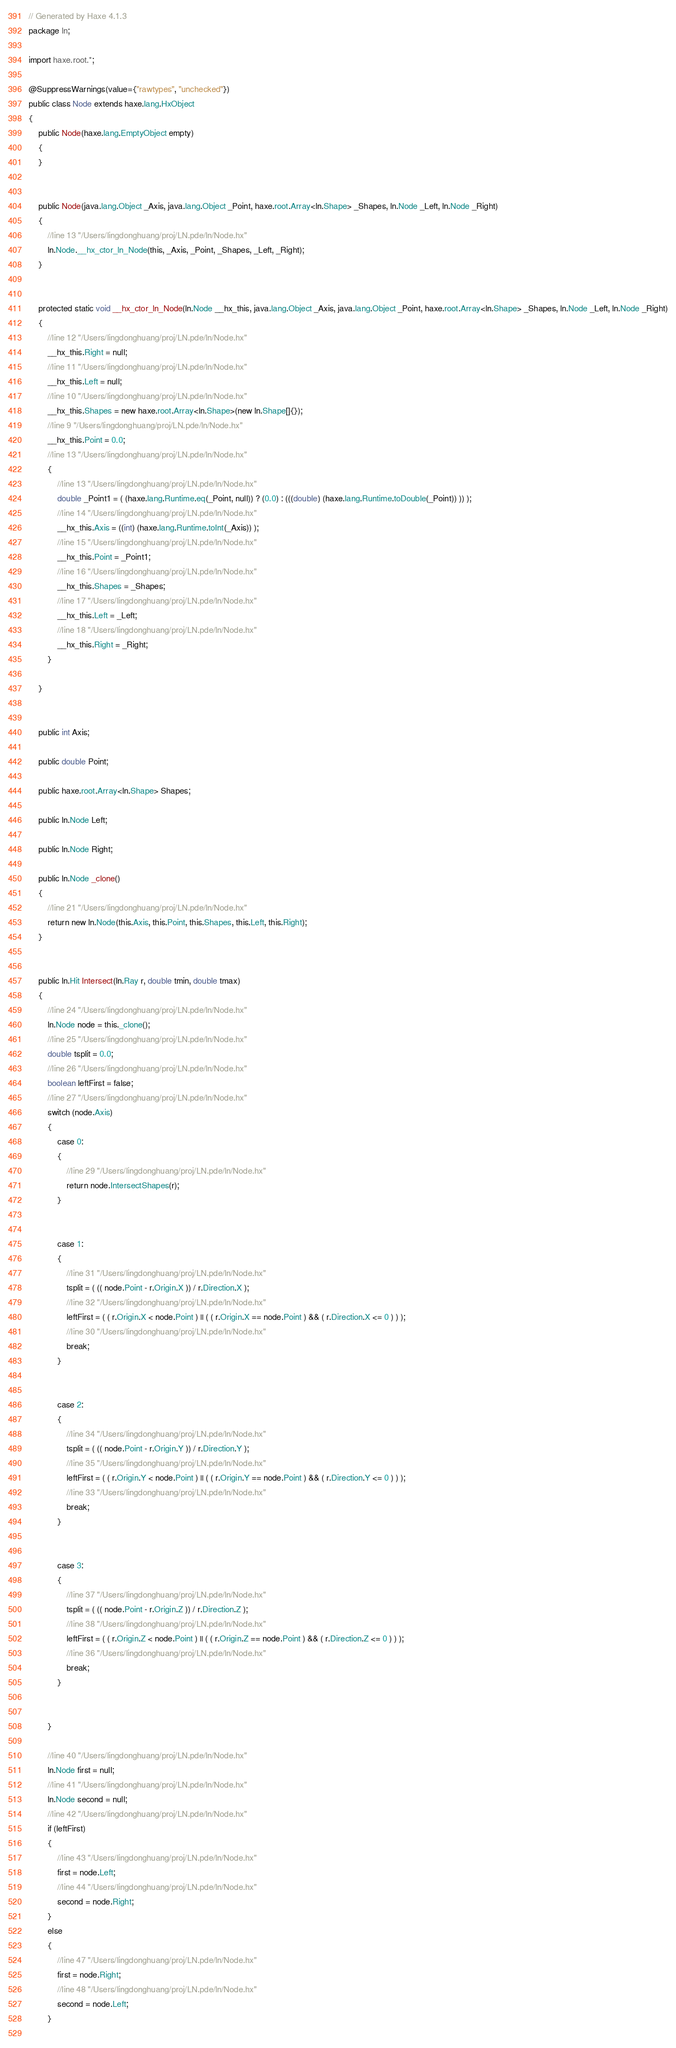<code> <loc_0><loc_0><loc_500><loc_500><_Java_>// Generated by Haxe 4.1.3
package ln;

import haxe.root.*;

@SuppressWarnings(value={"rawtypes", "unchecked"})
public class Node extends haxe.lang.HxObject
{
	public Node(haxe.lang.EmptyObject empty)
	{
	}
	
	
	public Node(java.lang.Object _Axis, java.lang.Object _Point, haxe.root.Array<ln.Shape> _Shapes, ln.Node _Left, ln.Node _Right)
	{
		//line 13 "/Users/lingdonghuang/proj/LN.pde/ln/Node.hx"
		ln.Node.__hx_ctor_ln_Node(this, _Axis, _Point, _Shapes, _Left, _Right);
	}
	
	
	protected static void __hx_ctor_ln_Node(ln.Node __hx_this, java.lang.Object _Axis, java.lang.Object _Point, haxe.root.Array<ln.Shape> _Shapes, ln.Node _Left, ln.Node _Right)
	{
		//line 12 "/Users/lingdonghuang/proj/LN.pde/ln/Node.hx"
		__hx_this.Right = null;
		//line 11 "/Users/lingdonghuang/proj/LN.pde/ln/Node.hx"
		__hx_this.Left = null;
		//line 10 "/Users/lingdonghuang/proj/LN.pde/ln/Node.hx"
		__hx_this.Shapes = new haxe.root.Array<ln.Shape>(new ln.Shape[]{});
		//line 9 "/Users/lingdonghuang/proj/LN.pde/ln/Node.hx"
		__hx_this.Point = 0.0;
		//line 13 "/Users/lingdonghuang/proj/LN.pde/ln/Node.hx"
		{
			//line 13 "/Users/lingdonghuang/proj/LN.pde/ln/Node.hx"
			double _Point1 = ( (haxe.lang.Runtime.eq(_Point, null)) ? (0.0) : (((double) (haxe.lang.Runtime.toDouble(_Point)) )) );
			//line 14 "/Users/lingdonghuang/proj/LN.pde/ln/Node.hx"
			__hx_this.Axis = ((int) (haxe.lang.Runtime.toInt(_Axis)) );
			//line 15 "/Users/lingdonghuang/proj/LN.pde/ln/Node.hx"
			__hx_this.Point = _Point1;
			//line 16 "/Users/lingdonghuang/proj/LN.pde/ln/Node.hx"
			__hx_this.Shapes = _Shapes;
			//line 17 "/Users/lingdonghuang/proj/LN.pde/ln/Node.hx"
			__hx_this.Left = _Left;
			//line 18 "/Users/lingdonghuang/proj/LN.pde/ln/Node.hx"
			__hx_this.Right = _Right;
		}
		
	}
	
	
	public int Axis;
	
	public double Point;
	
	public haxe.root.Array<ln.Shape> Shapes;
	
	public ln.Node Left;
	
	public ln.Node Right;
	
	public ln.Node _clone()
	{
		//line 21 "/Users/lingdonghuang/proj/LN.pde/ln/Node.hx"
		return new ln.Node(this.Axis, this.Point, this.Shapes, this.Left, this.Right);
	}
	
	
	public ln.Hit Intersect(ln.Ray r, double tmin, double tmax)
	{
		//line 24 "/Users/lingdonghuang/proj/LN.pde/ln/Node.hx"
		ln.Node node = this._clone();
		//line 25 "/Users/lingdonghuang/proj/LN.pde/ln/Node.hx"
		double tsplit = 0.0;
		//line 26 "/Users/lingdonghuang/proj/LN.pde/ln/Node.hx"
		boolean leftFirst = false;
		//line 27 "/Users/lingdonghuang/proj/LN.pde/ln/Node.hx"
		switch (node.Axis)
		{
			case 0:
			{
				//line 29 "/Users/lingdonghuang/proj/LN.pde/ln/Node.hx"
				return node.IntersectShapes(r);
			}
			
			
			case 1:
			{
				//line 31 "/Users/lingdonghuang/proj/LN.pde/ln/Node.hx"
				tsplit = ( (( node.Point - r.Origin.X )) / r.Direction.X );
				//line 32 "/Users/lingdonghuang/proj/LN.pde/ln/Node.hx"
				leftFirst = ( ( r.Origin.X < node.Point ) || ( ( r.Origin.X == node.Point ) && ( r.Direction.X <= 0 ) ) );
				//line 30 "/Users/lingdonghuang/proj/LN.pde/ln/Node.hx"
				break;
			}
			
			
			case 2:
			{
				//line 34 "/Users/lingdonghuang/proj/LN.pde/ln/Node.hx"
				tsplit = ( (( node.Point - r.Origin.Y )) / r.Direction.Y );
				//line 35 "/Users/lingdonghuang/proj/LN.pde/ln/Node.hx"
				leftFirst = ( ( r.Origin.Y < node.Point ) || ( ( r.Origin.Y == node.Point ) && ( r.Direction.Y <= 0 ) ) );
				//line 33 "/Users/lingdonghuang/proj/LN.pde/ln/Node.hx"
				break;
			}
			
			
			case 3:
			{
				//line 37 "/Users/lingdonghuang/proj/LN.pde/ln/Node.hx"
				tsplit = ( (( node.Point - r.Origin.Z )) / r.Direction.Z );
				//line 38 "/Users/lingdonghuang/proj/LN.pde/ln/Node.hx"
				leftFirst = ( ( r.Origin.Z < node.Point ) || ( ( r.Origin.Z == node.Point ) && ( r.Direction.Z <= 0 ) ) );
				//line 36 "/Users/lingdonghuang/proj/LN.pde/ln/Node.hx"
				break;
			}
			
			
		}
		
		//line 40 "/Users/lingdonghuang/proj/LN.pde/ln/Node.hx"
		ln.Node first = null;
		//line 41 "/Users/lingdonghuang/proj/LN.pde/ln/Node.hx"
		ln.Node second = null;
		//line 42 "/Users/lingdonghuang/proj/LN.pde/ln/Node.hx"
		if (leftFirst) 
		{
			//line 43 "/Users/lingdonghuang/proj/LN.pde/ln/Node.hx"
			first = node.Left;
			//line 44 "/Users/lingdonghuang/proj/LN.pde/ln/Node.hx"
			second = node.Right;
		}
		else
		{
			//line 47 "/Users/lingdonghuang/proj/LN.pde/ln/Node.hx"
			first = node.Right;
			//line 48 "/Users/lingdonghuang/proj/LN.pde/ln/Node.hx"
			second = node.Left;
		}
		</code> 